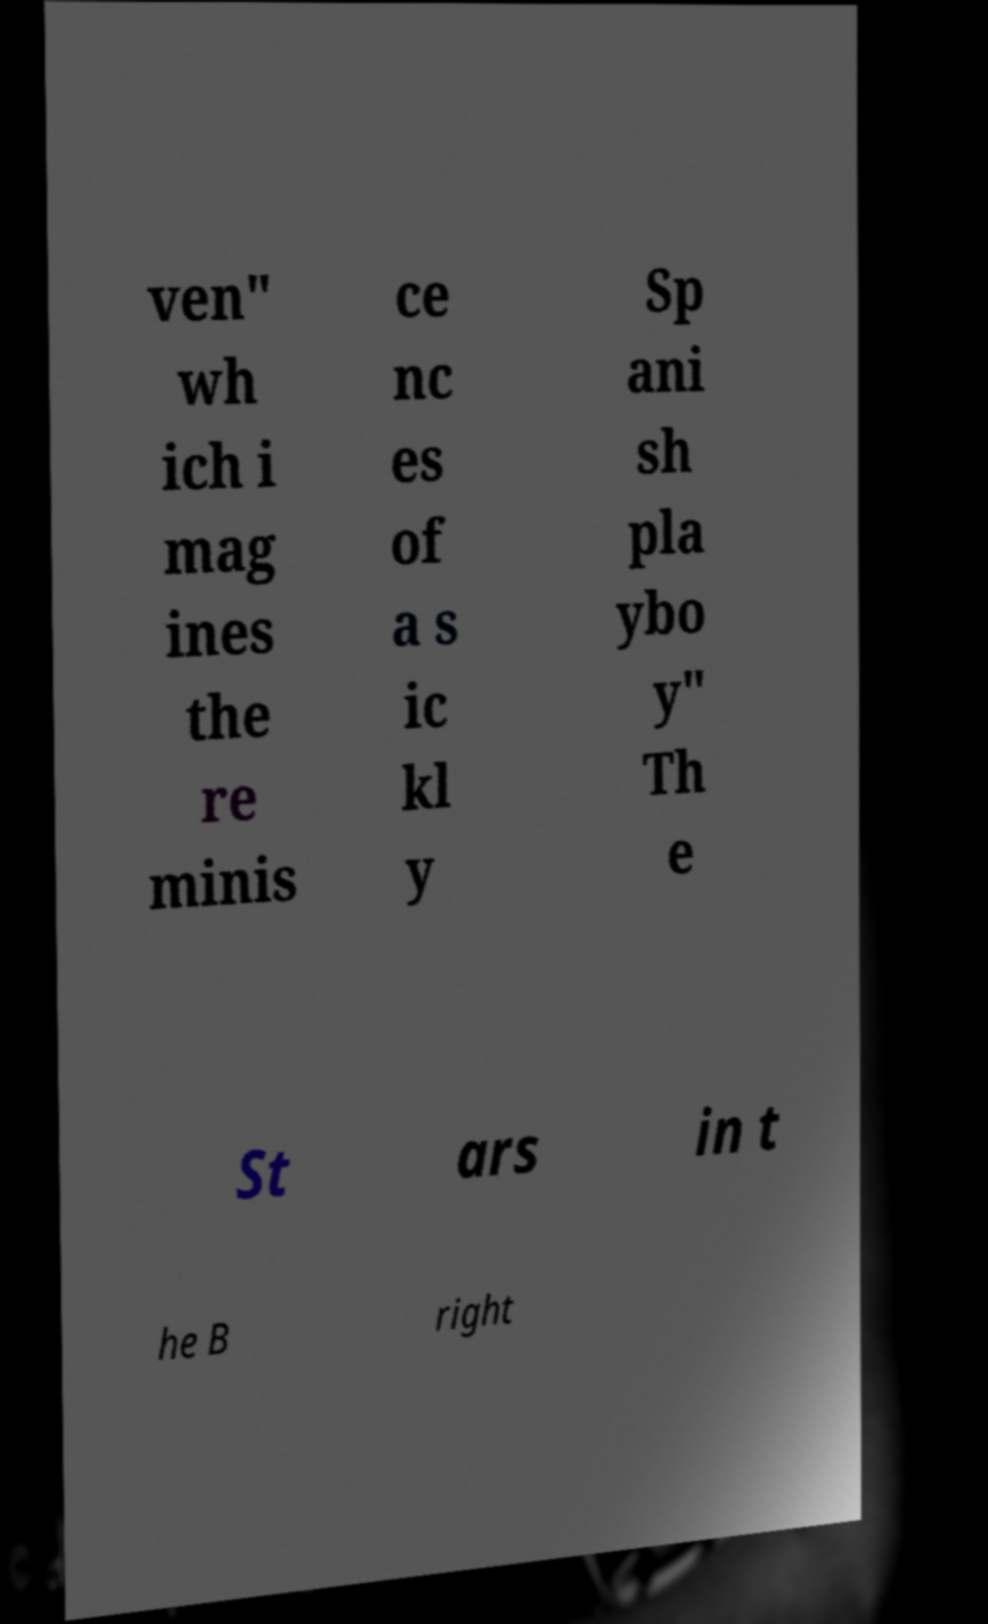For documentation purposes, I need the text within this image transcribed. Could you provide that? ven" wh ich i mag ines the re minis ce nc es of a s ic kl y Sp ani sh pla ybo y" Th e St ars in t he B right 